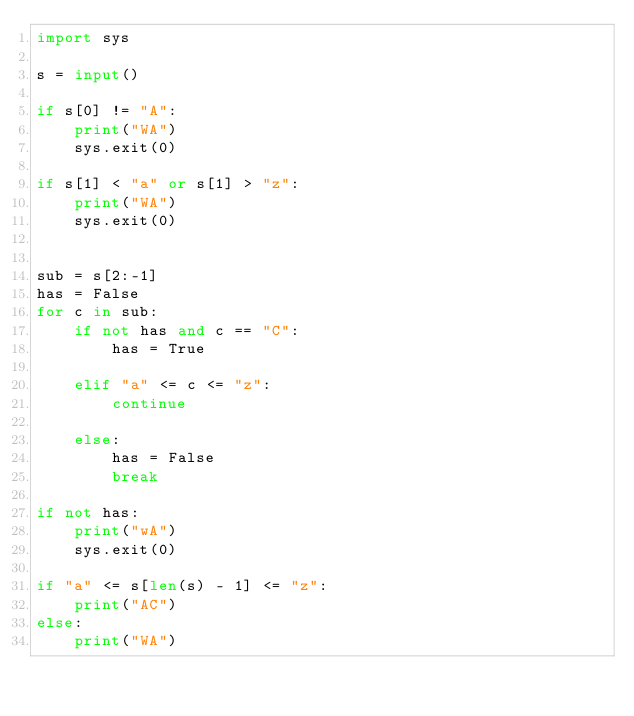<code> <loc_0><loc_0><loc_500><loc_500><_Python_>import sys

s = input()

if s[0] != "A":
    print("WA")
    sys.exit(0)

if s[1] < "a" or s[1] > "z":
    print("WA")
    sys.exit(0)


sub = s[2:-1]
has = False
for c in sub:
    if not has and c == "C":
        has = True

    elif "a" <= c <= "z":
        continue

    else:
        has = False
        break

if not has:
    print("wA")
    sys.exit(0)

if "a" <= s[len(s) - 1] <= "z":
    print("AC")
else:
    print("WA")
</code> 